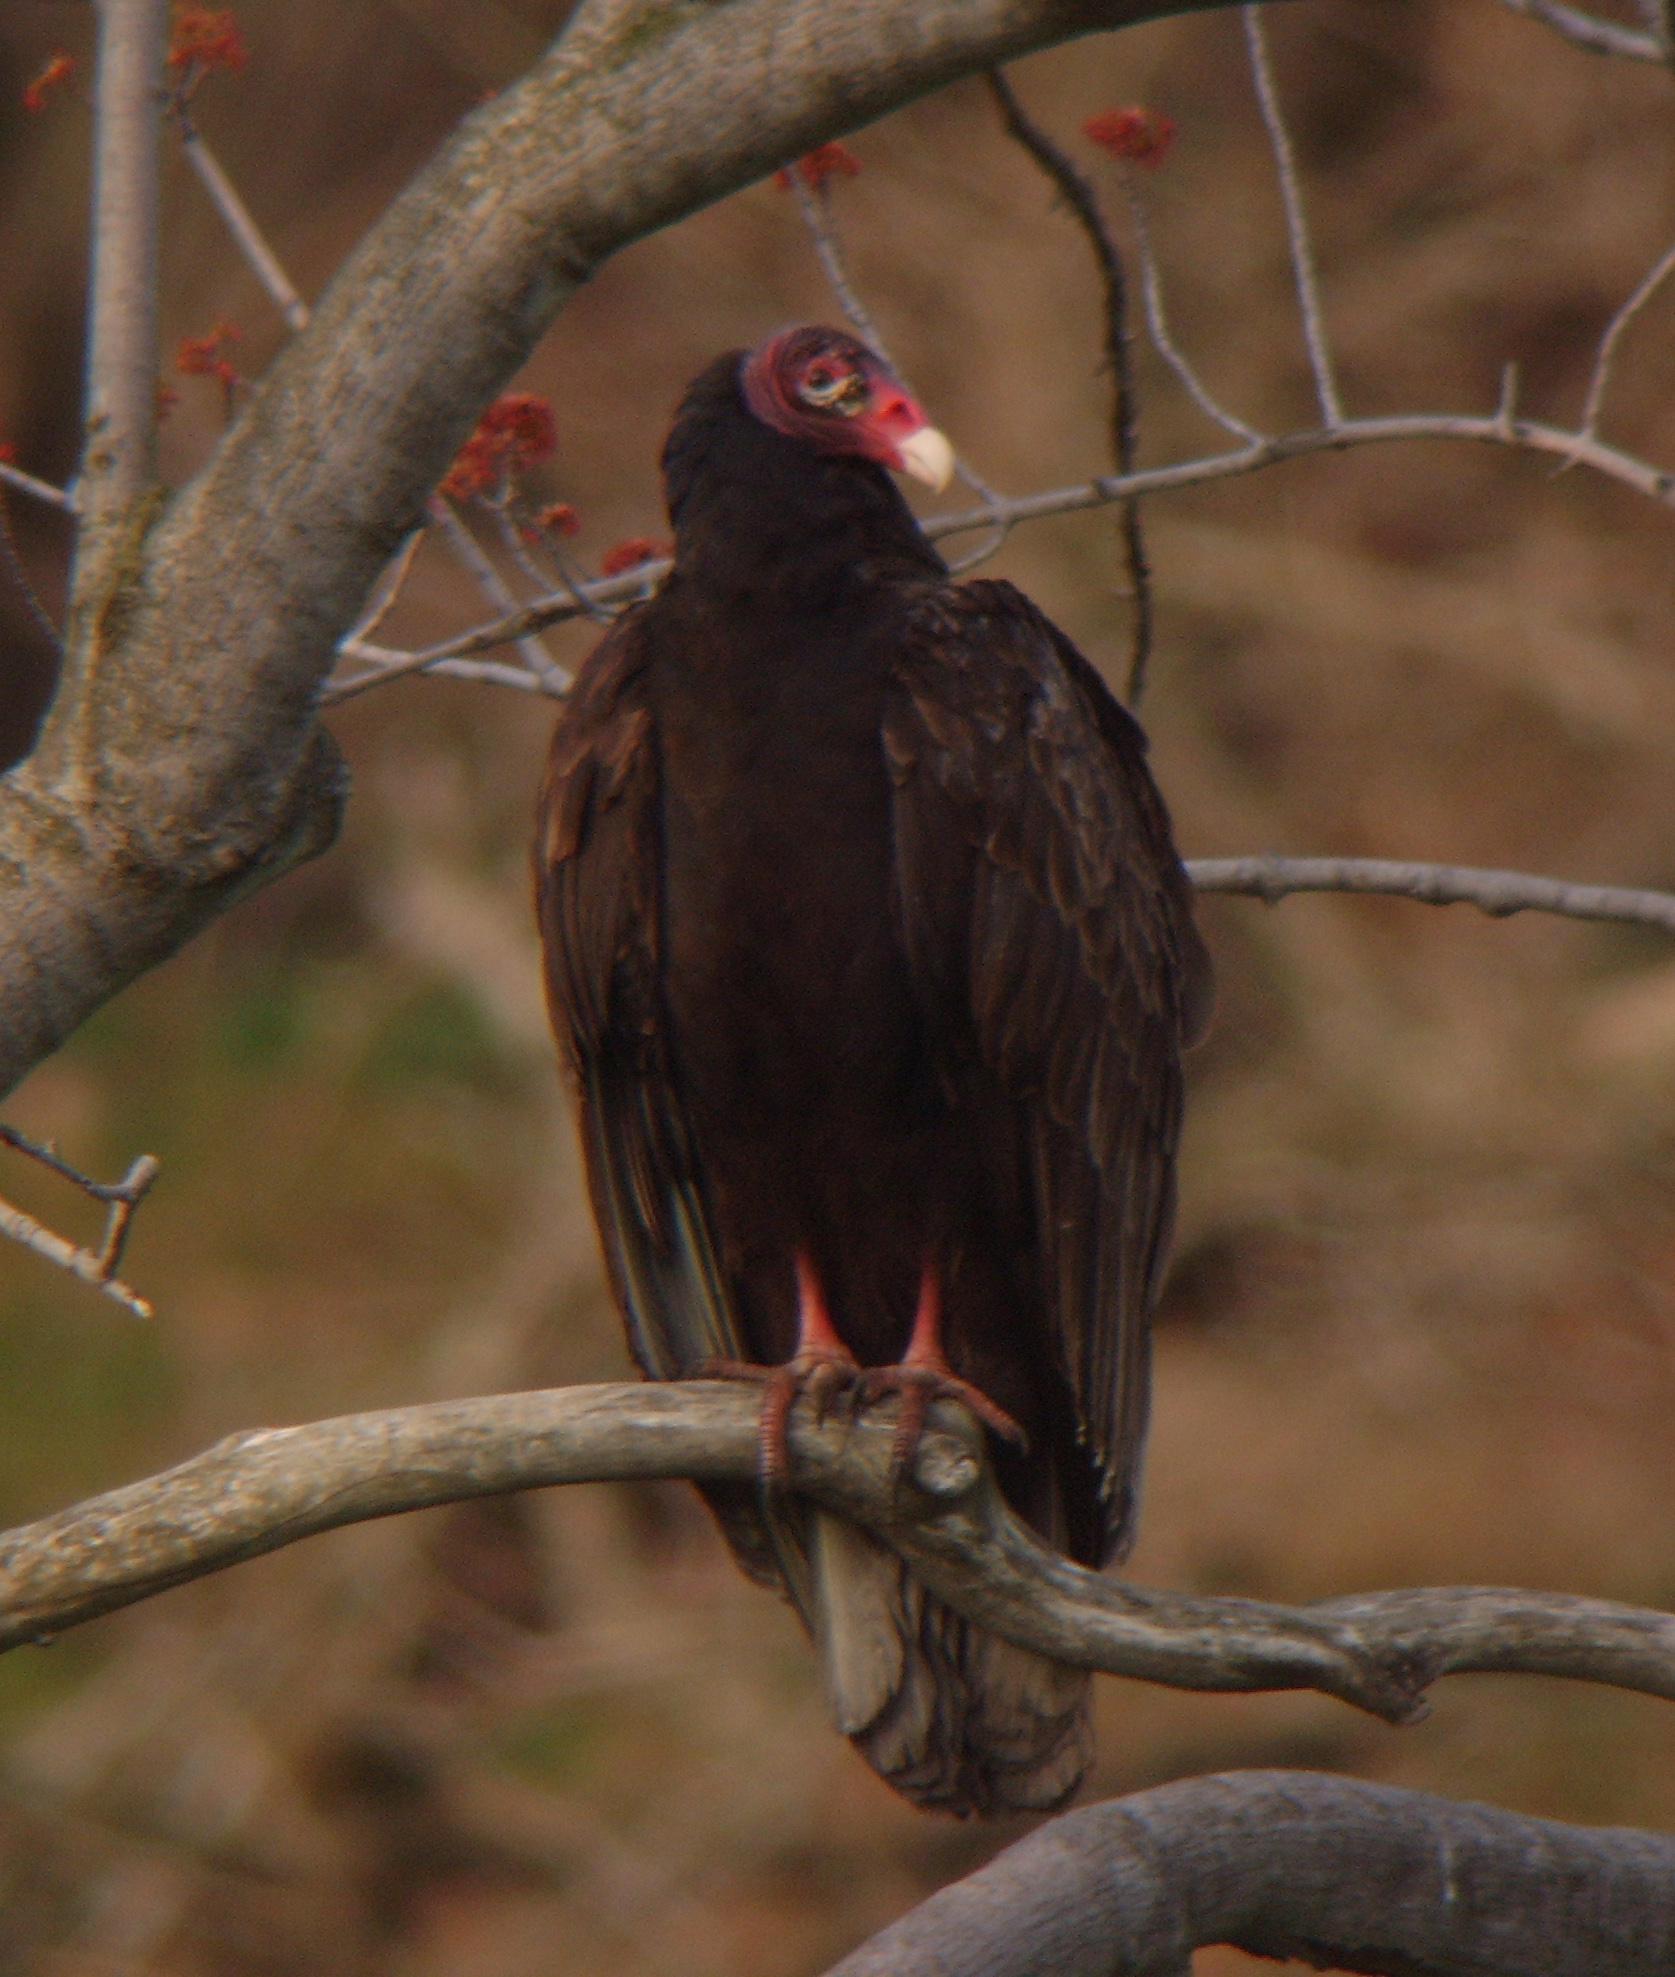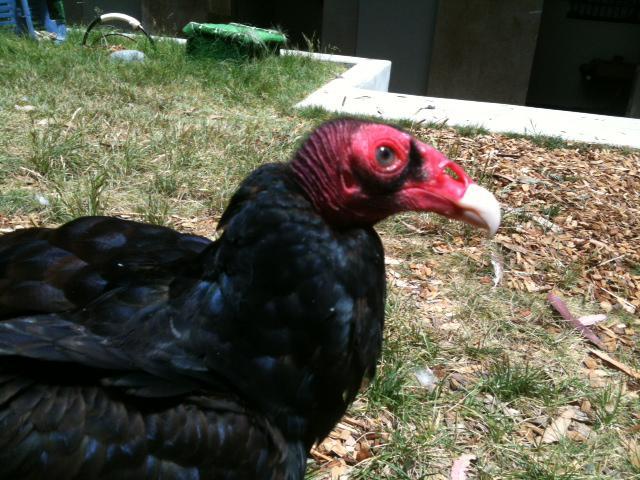The first image is the image on the left, the second image is the image on the right. Given the left and right images, does the statement "At least one buzzard is standing on a dead animal in one of the images." hold true? Answer yes or no. No. The first image is the image on the left, the second image is the image on the right. For the images shown, is this caption "An image shows one vulture perched on a wooden limb." true? Answer yes or no. Yes. 